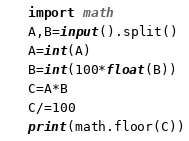Convert code to text. <code><loc_0><loc_0><loc_500><loc_500><_Python_>import math
A,B=input().split()
A=int(A)
B=int(100*float(B))
C=A*B
C/=100
print(math.floor(C))</code> 